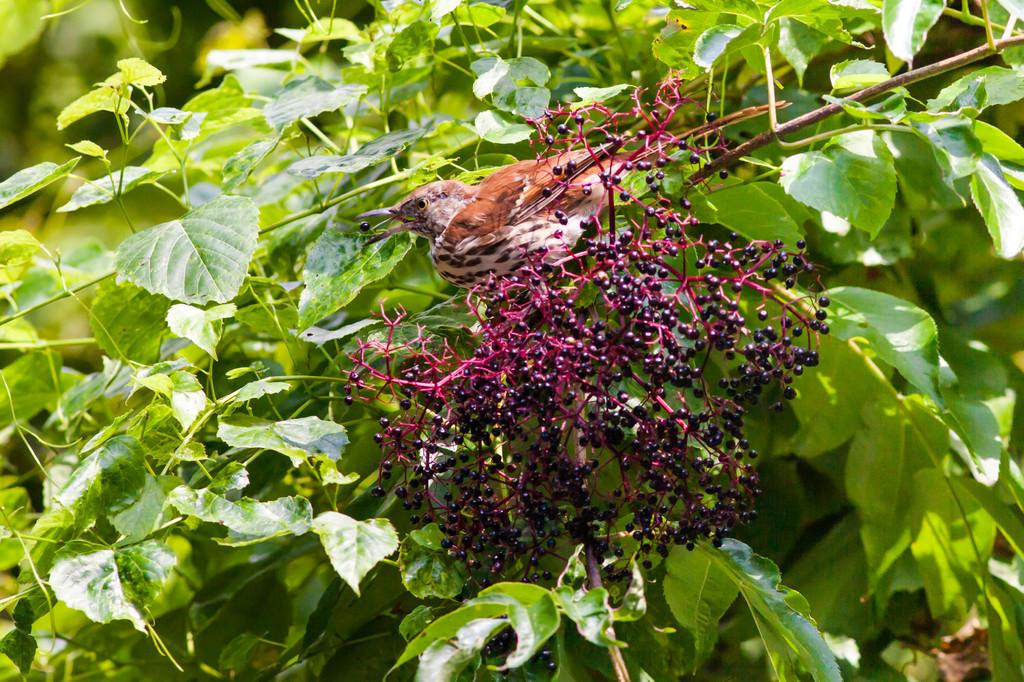What type of animal is present in the image? There is a bird in the image. What is the bird possibly eating in the image? There are berries in the image. What type of plant structure is visible in the image? There are branches in the image. What other part of the plant can be seen in the image? There are leaves in the image. What type of chain is the bird holding in the image? There is no chain present in the image. What does the caption say about the bird in the image? There is no caption present in the image. 